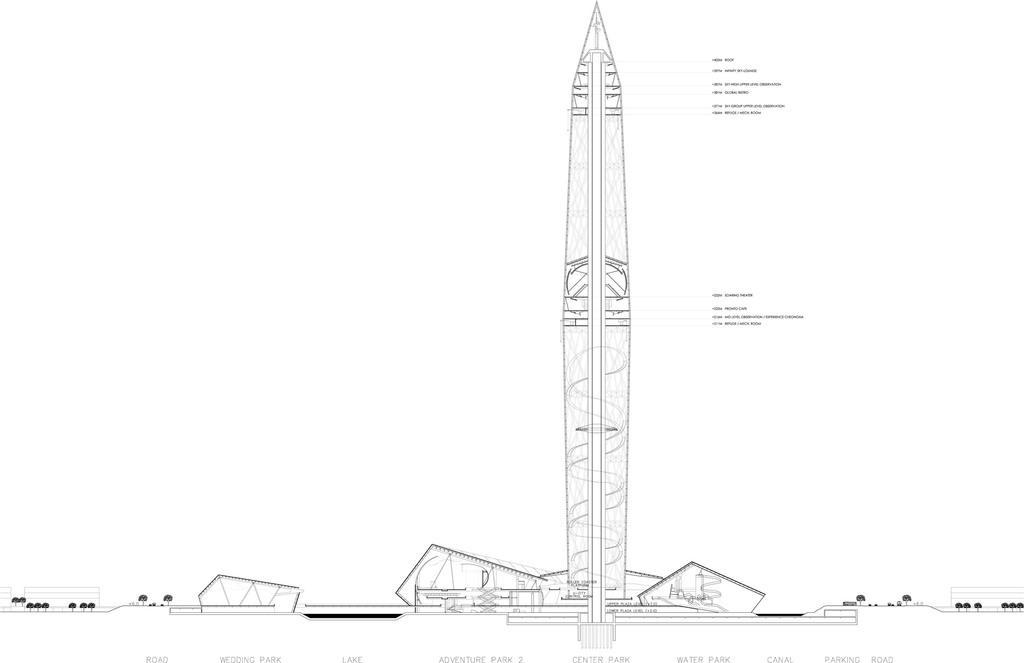Could you give a brief overview of what you see in this image? In this picture I can see there is a missile here and there are different parts of missile labelled and I can see there are buildings and trees here. 